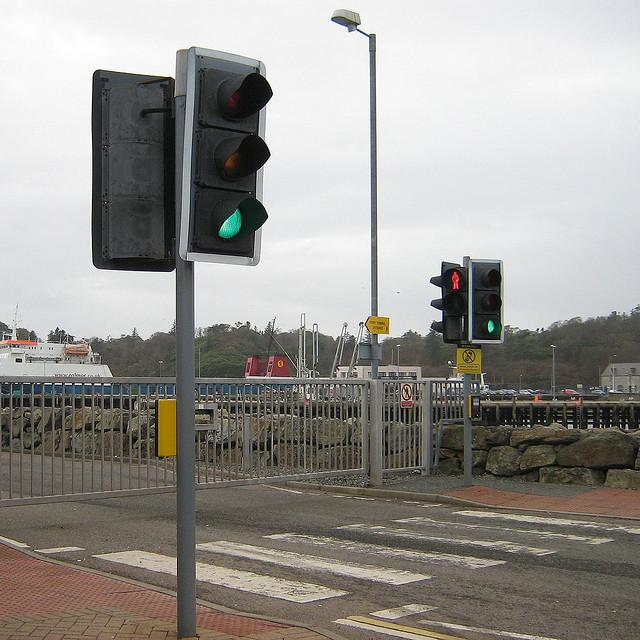What type of surface can be found past the rock wall to the right of the road? Please explain your reasoning. water. The surface has water. 